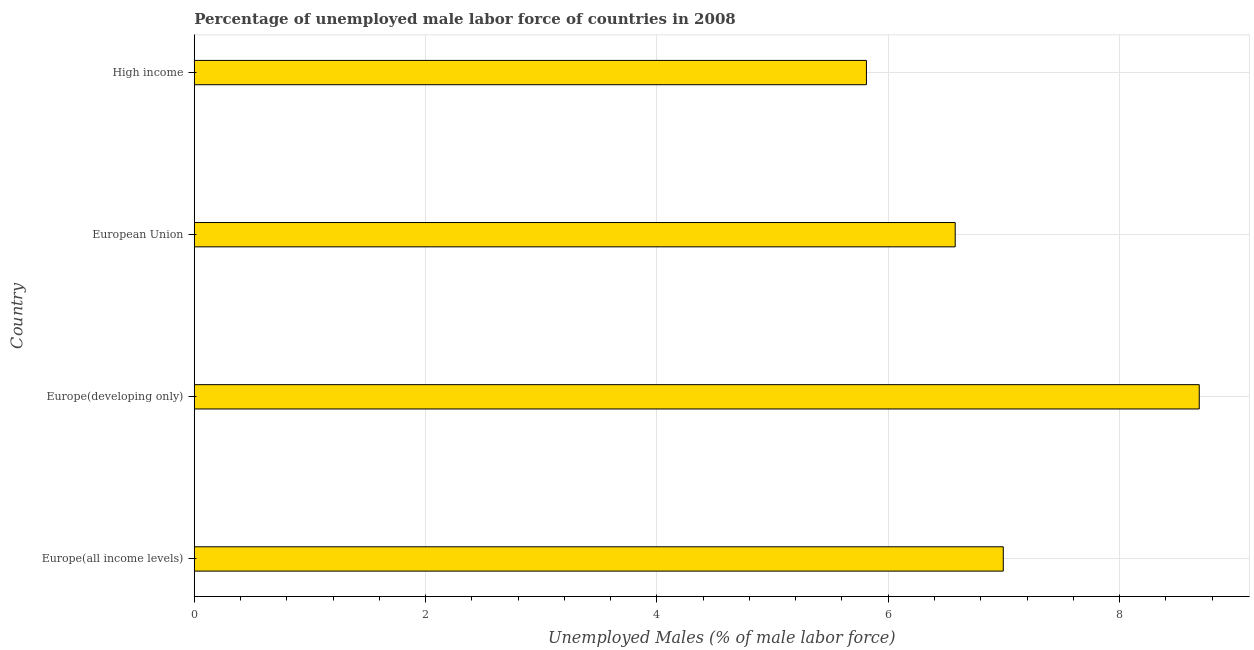What is the title of the graph?
Offer a terse response. Percentage of unemployed male labor force of countries in 2008. What is the label or title of the X-axis?
Give a very brief answer. Unemployed Males (% of male labor force). What is the total unemployed male labour force in Europe(all income levels)?
Offer a terse response. 6.99. Across all countries, what is the maximum total unemployed male labour force?
Make the answer very short. 8.69. Across all countries, what is the minimum total unemployed male labour force?
Offer a very short reply. 5.81. In which country was the total unemployed male labour force maximum?
Your response must be concise. Europe(developing only). What is the sum of the total unemployed male labour force?
Provide a short and direct response. 28.07. What is the difference between the total unemployed male labour force in Europe(developing only) and High income?
Your answer should be very brief. 2.88. What is the average total unemployed male labour force per country?
Offer a very short reply. 7.02. What is the median total unemployed male labour force?
Offer a terse response. 6.79. In how many countries, is the total unemployed male labour force greater than 0.8 %?
Your answer should be compact. 4. What is the ratio of the total unemployed male labour force in European Union to that in High income?
Keep it short and to the point. 1.13. Is the total unemployed male labour force in Europe(all income levels) less than that in European Union?
Give a very brief answer. No. Is the difference between the total unemployed male labour force in Europe(all income levels) and European Union greater than the difference between any two countries?
Offer a very short reply. No. What is the difference between the highest and the second highest total unemployed male labour force?
Ensure brevity in your answer.  1.69. What is the difference between the highest and the lowest total unemployed male labour force?
Provide a short and direct response. 2.88. How many bars are there?
Ensure brevity in your answer.  4. Are the values on the major ticks of X-axis written in scientific E-notation?
Your answer should be compact. No. What is the Unemployed Males (% of male labor force) in Europe(all income levels)?
Give a very brief answer. 6.99. What is the Unemployed Males (% of male labor force) in Europe(developing only)?
Your response must be concise. 8.69. What is the Unemployed Males (% of male labor force) in European Union?
Offer a terse response. 6.58. What is the Unemployed Males (% of male labor force) of High income?
Make the answer very short. 5.81. What is the difference between the Unemployed Males (% of male labor force) in Europe(all income levels) and Europe(developing only)?
Make the answer very short. -1.69. What is the difference between the Unemployed Males (% of male labor force) in Europe(all income levels) and European Union?
Ensure brevity in your answer.  0.42. What is the difference between the Unemployed Males (% of male labor force) in Europe(all income levels) and High income?
Your answer should be very brief. 1.18. What is the difference between the Unemployed Males (% of male labor force) in Europe(developing only) and European Union?
Offer a very short reply. 2.11. What is the difference between the Unemployed Males (% of male labor force) in Europe(developing only) and High income?
Ensure brevity in your answer.  2.88. What is the difference between the Unemployed Males (% of male labor force) in European Union and High income?
Your answer should be compact. 0.77. What is the ratio of the Unemployed Males (% of male labor force) in Europe(all income levels) to that in Europe(developing only)?
Keep it short and to the point. 0.81. What is the ratio of the Unemployed Males (% of male labor force) in Europe(all income levels) to that in European Union?
Give a very brief answer. 1.06. What is the ratio of the Unemployed Males (% of male labor force) in Europe(all income levels) to that in High income?
Offer a very short reply. 1.2. What is the ratio of the Unemployed Males (% of male labor force) in Europe(developing only) to that in European Union?
Provide a succinct answer. 1.32. What is the ratio of the Unemployed Males (% of male labor force) in Europe(developing only) to that in High income?
Make the answer very short. 1.5. What is the ratio of the Unemployed Males (% of male labor force) in European Union to that in High income?
Offer a very short reply. 1.13. 